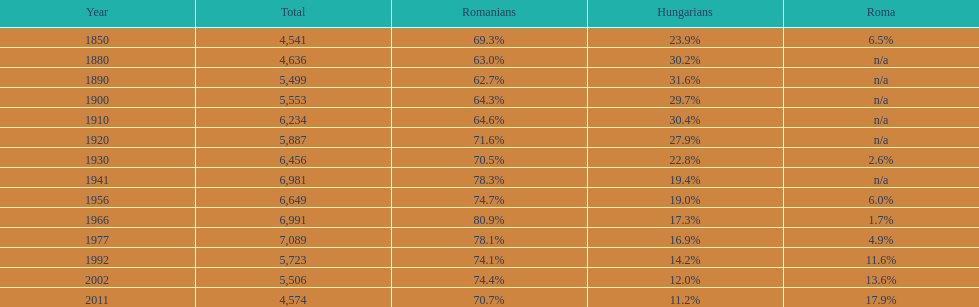4%? 1941. Can you parse all the data within this table? {'header': ['Year', 'Total', 'Romanians', 'Hungarians', 'Roma'], 'rows': [['1850', '4,541', '69.3%', '23.9%', '6.5%'], ['1880', '4,636', '63.0%', '30.2%', 'n/a'], ['1890', '5,499', '62.7%', '31.6%', 'n/a'], ['1900', '5,553', '64.3%', '29.7%', 'n/a'], ['1910', '6,234', '64.6%', '30.4%', 'n/a'], ['1920', '5,887', '71.6%', '27.9%', 'n/a'], ['1930', '6,456', '70.5%', '22.8%', '2.6%'], ['1941', '6,981', '78.3%', '19.4%', 'n/a'], ['1956', '6,649', '74.7%', '19.0%', '6.0%'], ['1966', '6,991', '80.9%', '17.3%', '1.7%'], ['1977', '7,089', '78.1%', '16.9%', '4.9%'], ['1992', '5,723', '74.1%', '14.2%', '11.6%'], ['2002', '5,506', '74.4%', '12.0%', '13.6%'], ['2011', '4,574', '70.7%', '11.2%', '17.9%']]} 